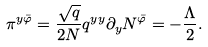Convert formula to latex. <formula><loc_0><loc_0><loc_500><loc_500>\pi ^ { y { \bar { \varphi } } } = \frac { \sqrt { q } } { 2 N } q ^ { y y } \partial _ { y } N ^ { \bar { \varphi } } = - \frac { \Lambda } { 2 } .</formula> 